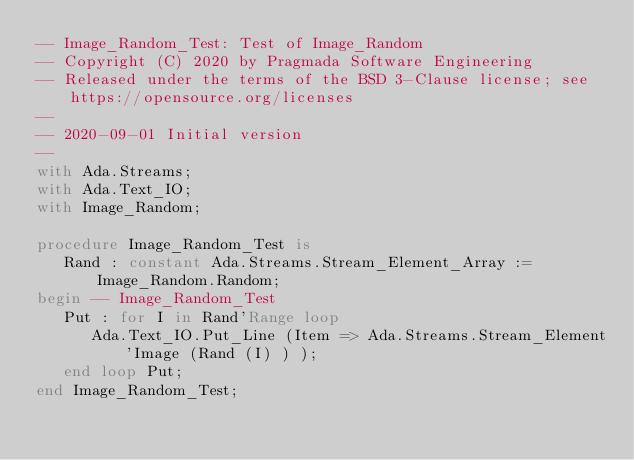Convert code to text. <code><loc_0><loc_0><loc_500><loc_500><_Ada_>-- Image_Random_Test: Test of Image_Random
-- Copyright (C) 2020 by Pragmada Software Engineering
-- Released under the terms of the BSD 3-Clause license; see https://opensource.org/licenses
--
-- 2020-09-01 Initial version
--
with Ada.Streams;
with Ada.Text_IO;
with Image_Random;

procedure Image_Random_Test is
   Rand : constant Ada.Streams.Stream_Element_Array := Image_Random.Random;
begin -- Image_Random_Test
   Put : for I in Rand'Range loop
      Ada.Text_IO.Put_Line (Item => Ada.Streams.Stream_Element'Image (Rand (I) ) );
   end loop Put;
end Image_Random_Test;
</code> 